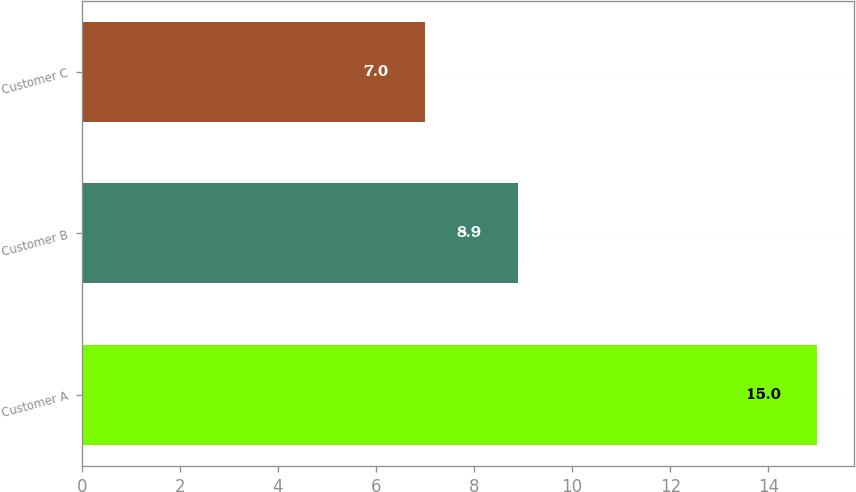<chart> <loc_0><loc_0><loc_500><loc_500><bar_chart><fcel>Customer A<fcel>Customer B<fcel>Customer C<nl><fcel>15<fcel>8.9<fcel>7<nl></chart> 